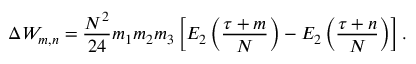<formula> <loc_0><loc_0><loc_500><loc_500>\Delta W _ { m , n } = \frac { N ^ { 2 } } { 2 4 } m _ { 1 } m _ { 2 } m _ { 3 } \left [ E _ { 2 } \left ( \frac { \tau + m } { N } \right ) - E _ { 2 } \left ( \frac { \tau + n } { N } \right ) \right ] .</formula> 